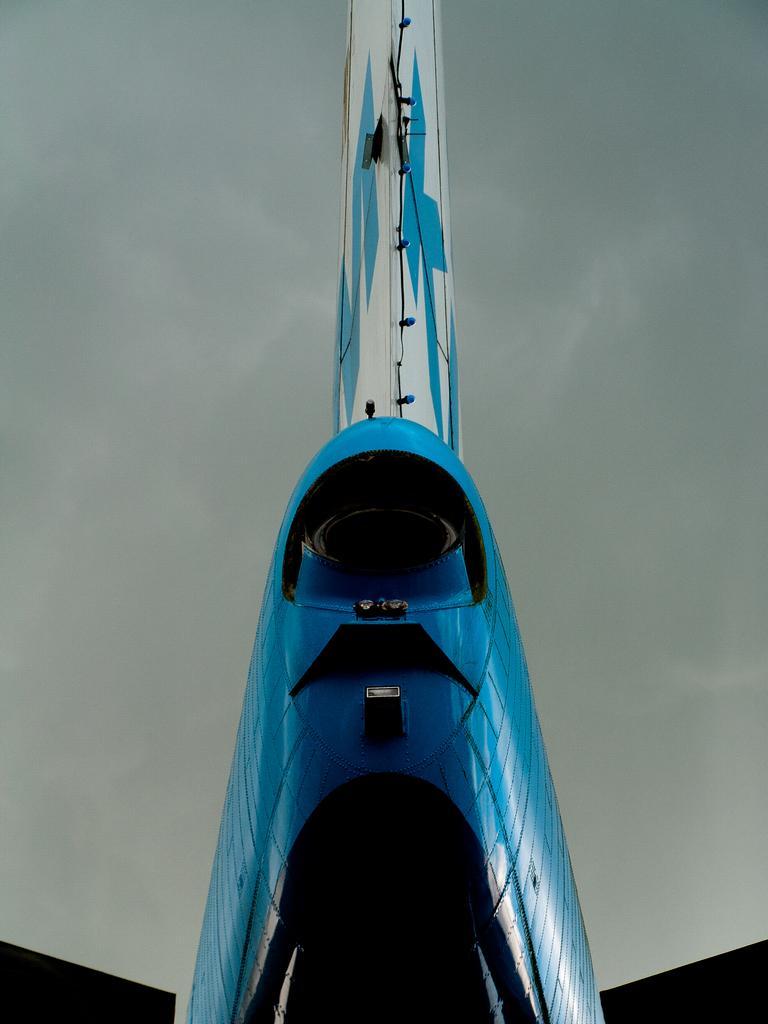Can you describe this image briefly? In the foreground I can see an object. In the background I can see the sky. This image is taken may be during a day. 